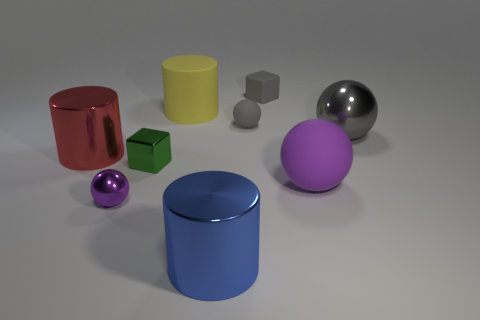Which objects seem to be similar in color? The small sphere and the large cylinder in the foreground seem to share a similar shade of blue, suggesting a visual connection between them. 